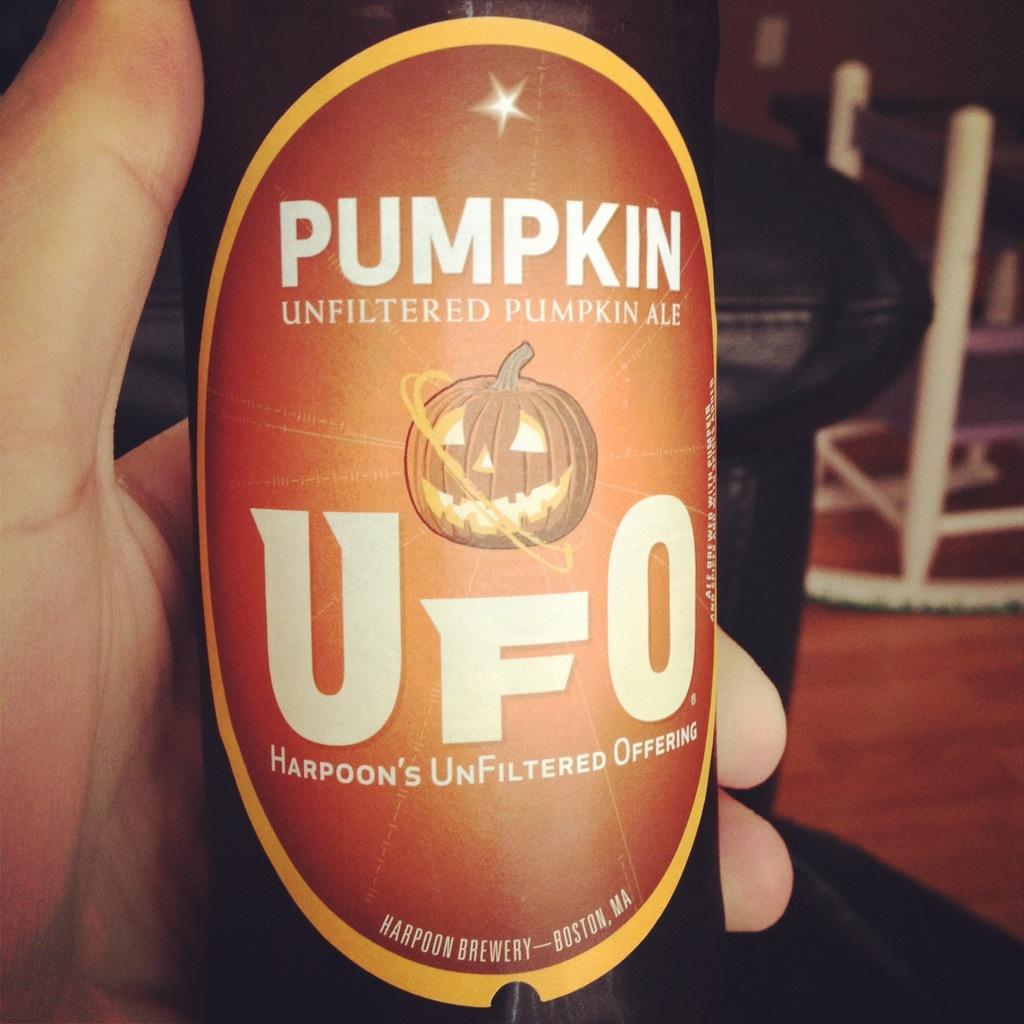Please provide a concise description of this image. In front of the image we can see the hand of a person holding some object. On the right side of the image there are a few objects on the floor. In the background of the image there is a wall. 